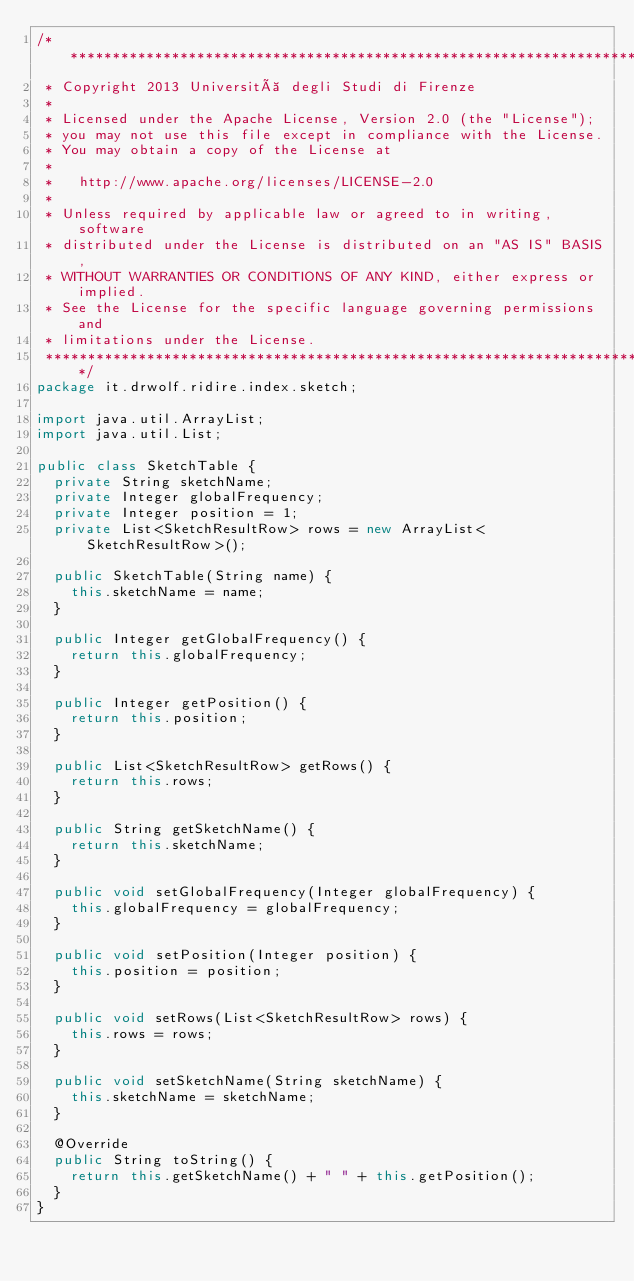Convert code to text. <code><loc_0><loc_0><loc_500><loc_500><_Java_>/*******************************************************************************
 * Copyright 2013 Università degli Studi di Firenze
 * 
 * Licensed under the Apache License, Version 2.0 (the "License");
 * you may not use this file except in compliance with the License.
 * You may obtain a copy of the License at
 * 
 *   http://www.apache.org/licenses/LICENSE-2.0
 * 
 * Unless required by applicable law or agreed to in writing, software
 * distributed under the License is distributed on an "AS IS" BASIS,
 * WITHOUT WARRANTIES OR CONDITIONS OF ANY KIND, either express or implied.
 * See the License for the specific language governing permissions and
 * limitations under the License.
 ******************************************************************************/
package it.drwolf.ridire.index.sketch;

import java.util.ArrayList;
import java.util.List;

public class SketchTable {
	private String sketchName;
	private Integer globalFrequency;
	private Integer position = 1;
	private List<SketchResultRow> rows = new ArrayList<SketchResultRow>();

	public SketchTable(String name) {
		this.sketchName = name;
	}

	public Integer getGlobalFrequency() {
		return this.globalFrequency;
	}

	public Integer getPosition() {
		return this.position;
	}

	public List<SketchResultRow> getRows() {
		return this.rows;
	}

	public String getSketchName() {
		return this.sketchName;
	}

	public void setGlobalFrequency(Integer globalFrequency) {
		this.globalFrequency = globalFrequency;
	}

	public void setPosition(Integer position) {
		this.position = position;
	}

	public void setRows(List<SketchResultRow> rows) {
		this.rows = rows;
	}

	public void setSketchName(String sketchName) {
		this.sketchName = sketchName;
	}

	@Override
	public String toString() {
		return this.getSketchName() + " " + this.getPosition();
	}
}
</code> 